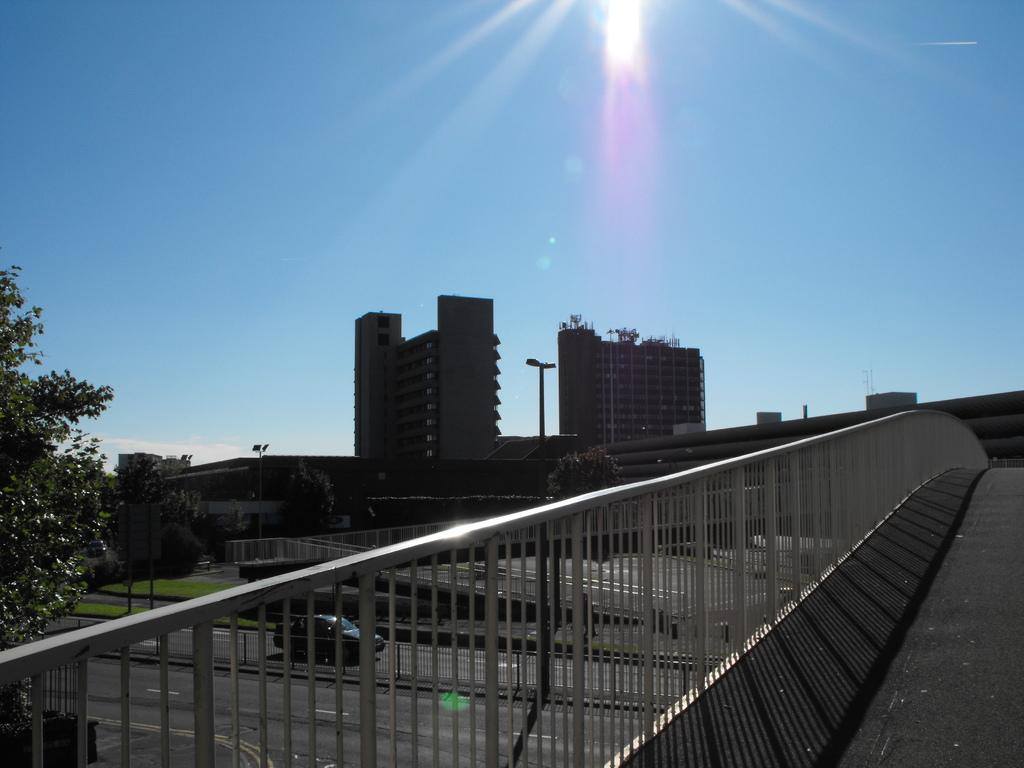What types of structures are visible in the image? There are buildings in the image. What other natural elements can be seen in the image? There are trees in the image. What is visible in the background of the image? The sky is visible in the image. What type of plastic is being sorted in the image? There is no plastic or sorting activity present in the image. 